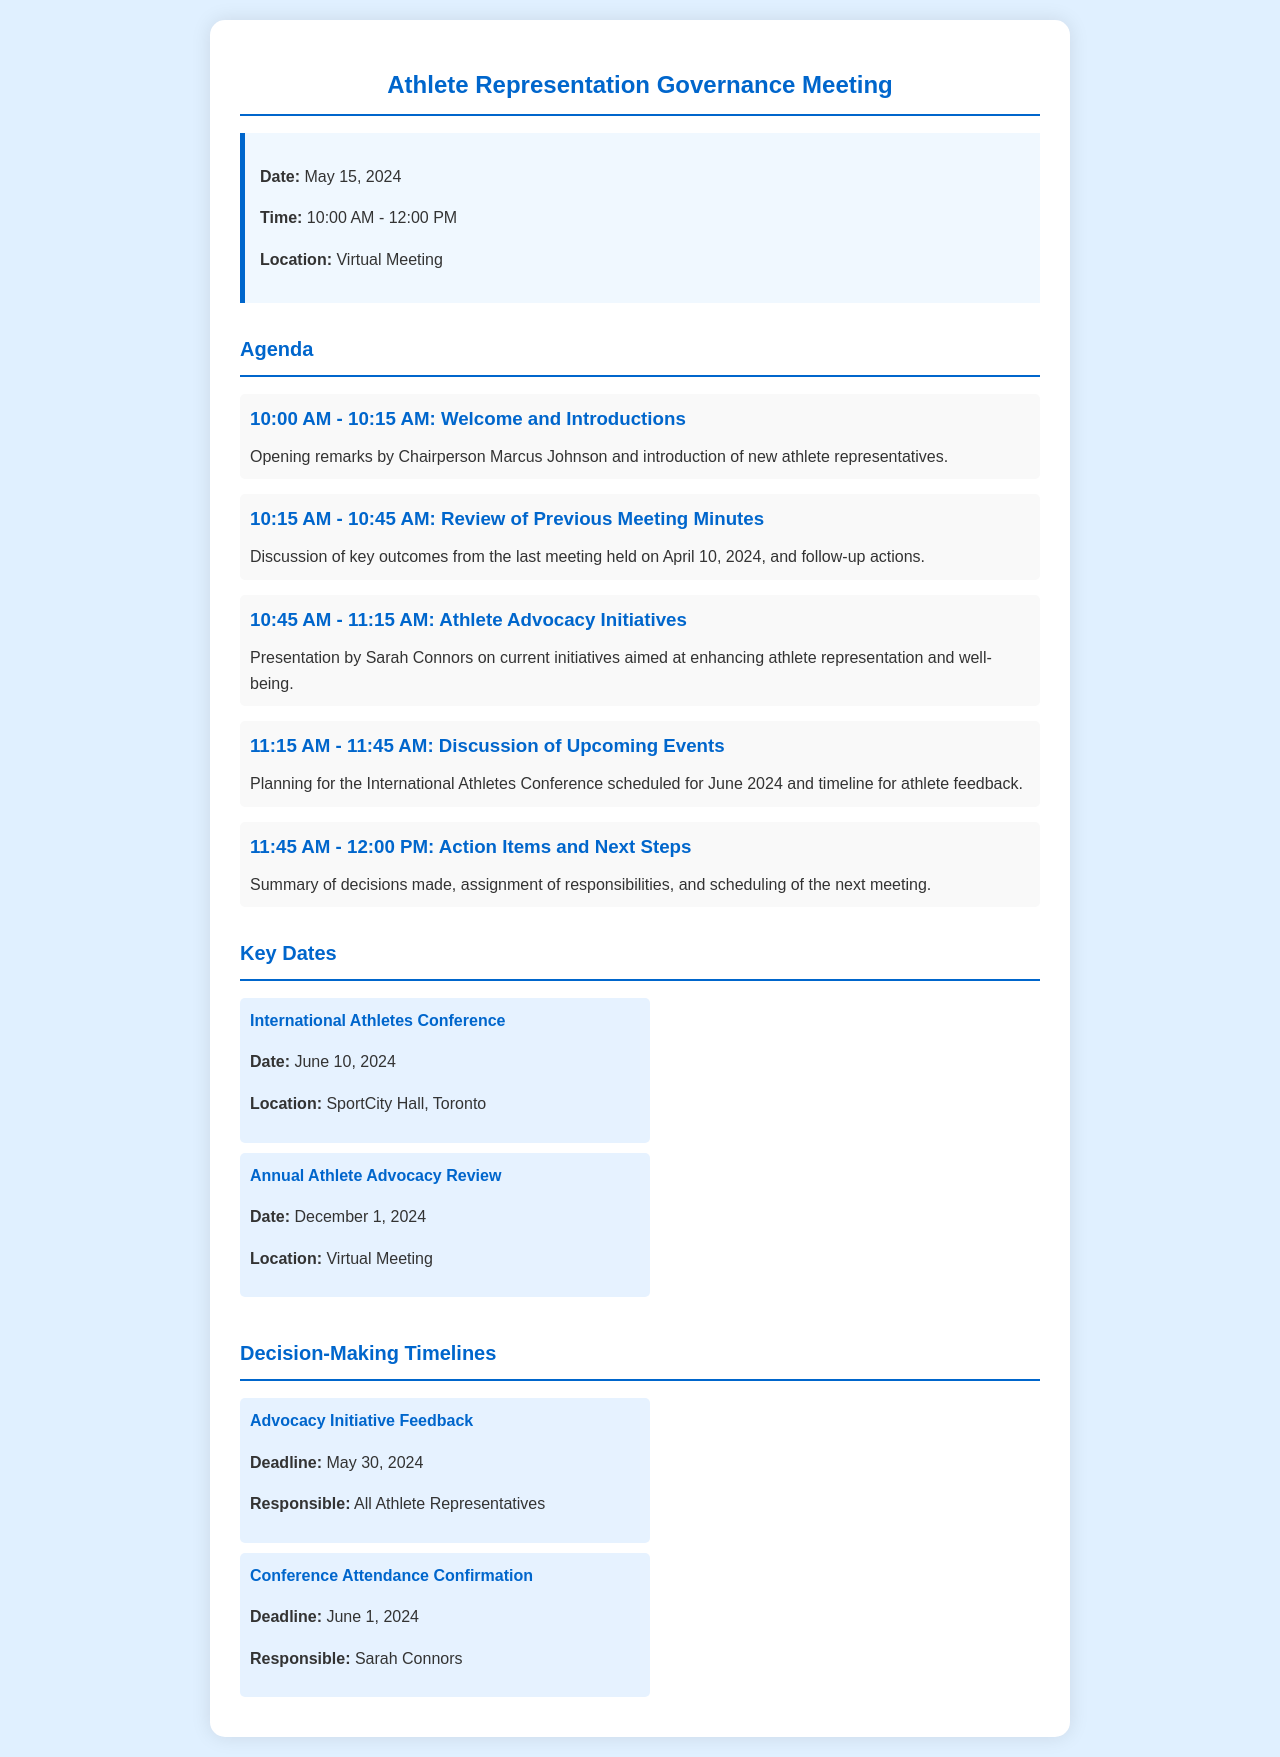what is the date of the governance meeting? The date of the meeting is clearly stated in the meeting info section of the document.
Answer: May 15, 2024 who is the chairperson for the meeting? The chairperson is mentioned in the first agenda item, providing specific names related to the opening remarks.
Answer: Marcus Johnson what time does the meeting start? The start time is noted in the meeting info section, indicating the beginning of the scheduled meeting.
Answer: 10:00 AM what is the location of the International Athletes Conference? The location for this event is listed under the key dates section, addressing important venues for athlete events.
Answer: SportCity Hall, Toronto when is the deadline for advocacy initiative feedback? The deadline is specified in the decision-making timelines section, which outlines key responsibilities and deadlines.
Answer: May 30, 2024 how long is the advocacy initiatives discussion scheduled for? The duration for this agenda item can be calculated from the time allocated in the agenda, showing how discussions are structured.
Answer: 30 minutes what are the major topics covered in the agenda? The agenda outlines the main topics to be discussed in the meeting, covering various aspects of athlete representation governance.
Answer: Welcome and Introductions, Review of Previous Meeting Minutes, Athlete Advocacy Initiatives, Discussion of Upcoming Events, Action Items and Next Steps who is responsible for confirming conference attendance? The responsible individual is mentioned directly in the decision-making timelines section, detailing accountability for tasks.
Answer: Sarah Connors 